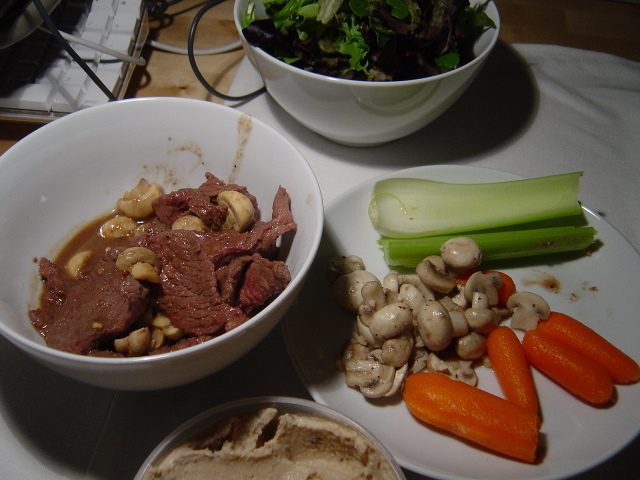<image>What sort of condiment has been drizzled on the dish? I don't know the exact type of condiment drizzled on the dish, but it might be gravy, mayo, or soy sauce. What sort of condiment has been drizzled on the dish? It is unclear what sort of condiment has been drizzled on the dish. It can be seen gravy, mayo, soy sauce or sauce. 